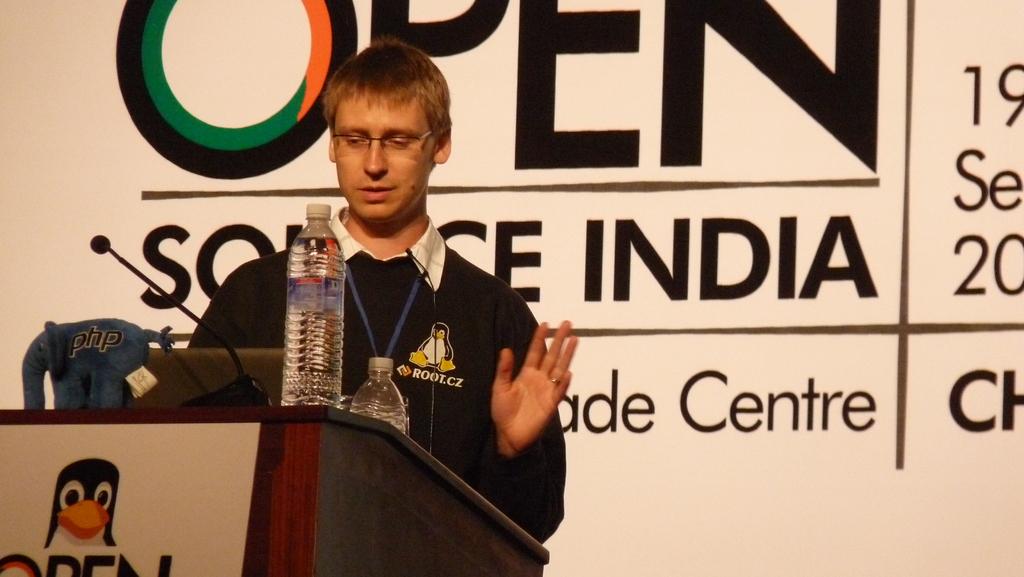Where is the open source?
Ensure brevity in your answer.  India. 